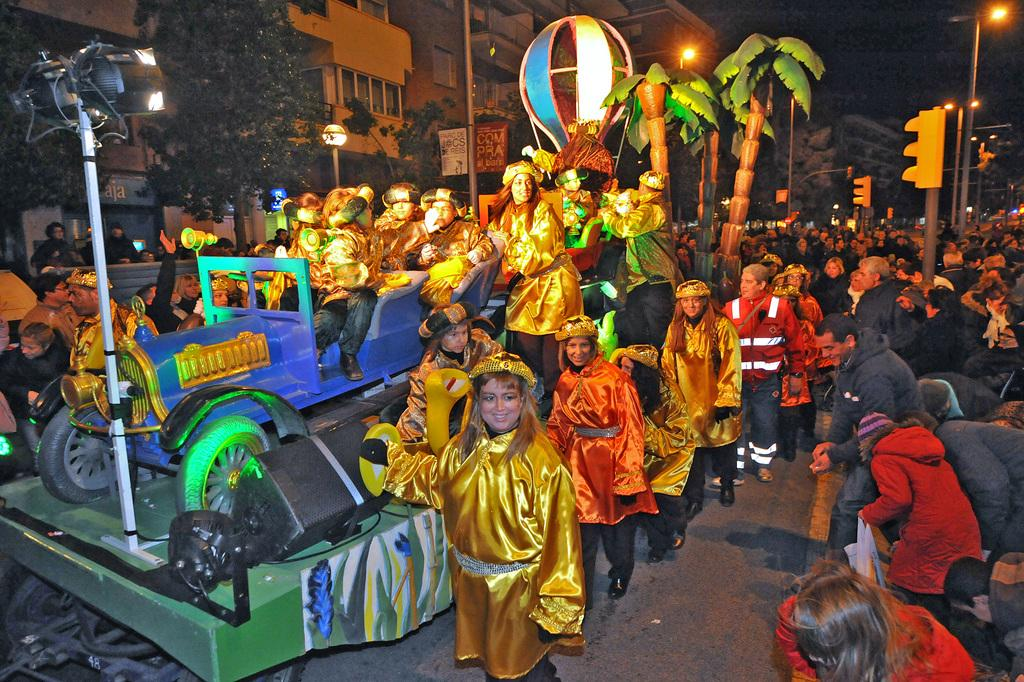Who or what is present in the image? There are people in the image. What can be seen on the right side of the image? There is a vehicle on the right side of the image. What type of natural elements are visible in the image? There are trees in the image. What type of man-made structures are visible in the image? There are buildings in the image. What is visible at the top of the image? There are lights visible at the top of the image. What type of nut is being used as a quill to write on the berry in the image? There is no nut, quill, or berry present in the image. 